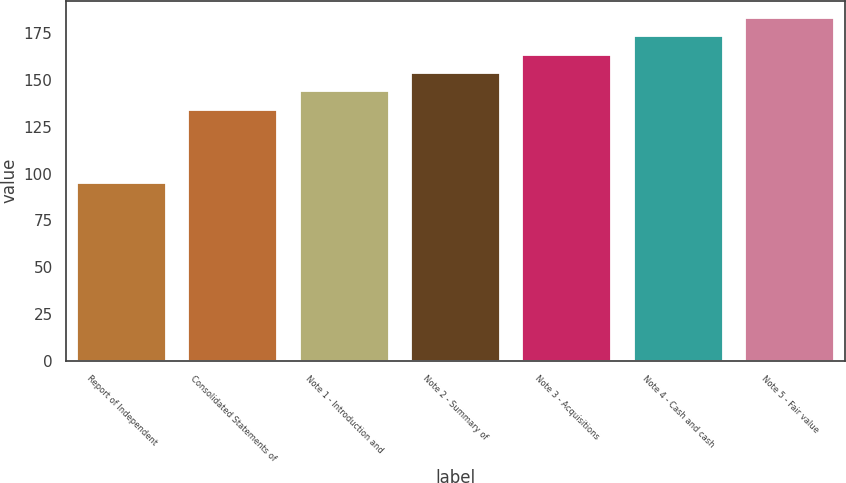Convert chart. <chart><loc_0><loc_0><loc_500><loc_500><bar_chart><fcel>Report of Independent<fcel>Consolidated Statements of<fcel>Note 1 - Introduction and<fcel>Note 2 - Summary of<fcel>Note 3 - Acquisitions<fcel>Note 4 - Cash and cash<fcel>Note 5 - Fair value<nl><fcel>95<fcel>134.2<fcel>144<fcel>153.8<fcel>163.6<fcel>173.4<fcel>183.2<nl></chart> 